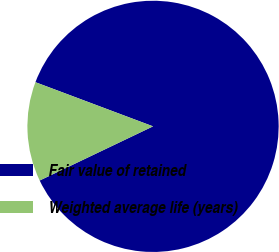Convert chart. <chart><loc_0><loc_0><loc_500><loc_500><pie_chart><fcel>Fair value of retained<fcel>Weighted average life (years)<nl><fcel>87.19%<fcel>12.81%<nl></chart> 